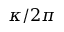Convert formula to latex. <formula><loc_0><loc_0><loc_500><loc_500>\kappa / 2 \pi</formula> 